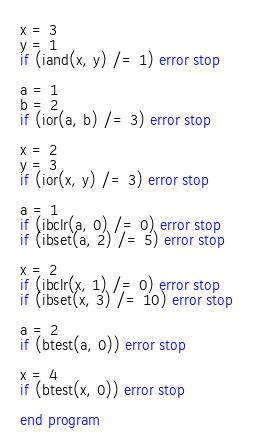Convert code to text. <code><loc_0><loc_0><loc_500><loc_500><_FORTRAN_>x = 3
y = 1
if (iand(x, y) /= 1) error stop

a = 1
b = 2
if (ior(a, b) /= 3) error stop

x = 2
y = 3
if (ior(x, y) /= 3) error stop

a = 1
if (ibclr(a, 0) /= 0) error stop
if (ibset(a, 2) /= 5) error stop

x = 2
if (ibclr(x, 1) /= 0) error stop
if (ibset(x, 3) /= 10) error stop

a = 2
if (btest(a, 0)) error stop

x = 4
if (btest(x, 0)) error stop

end program
</code> 